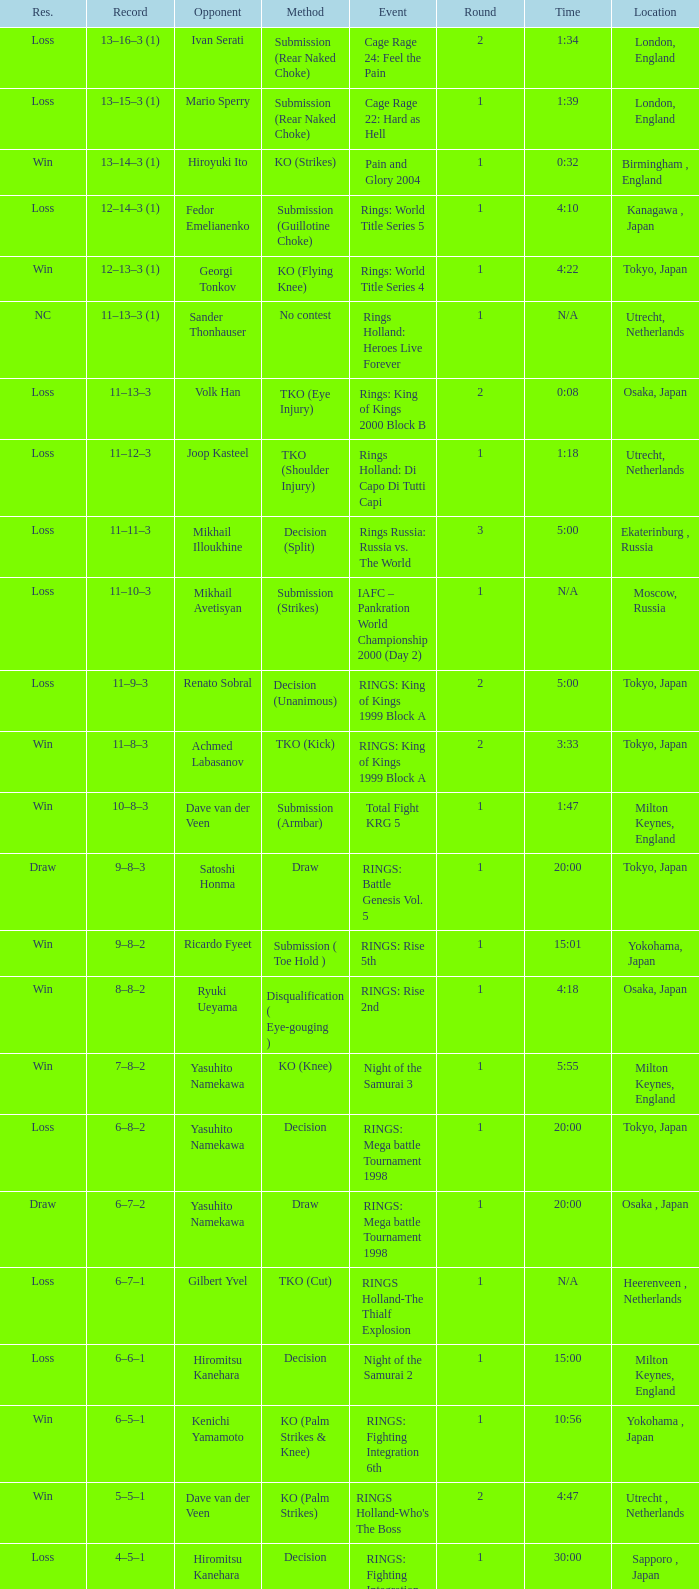Who faced off in a match with less than 2 rounds in london, england? Mario Sperry. 